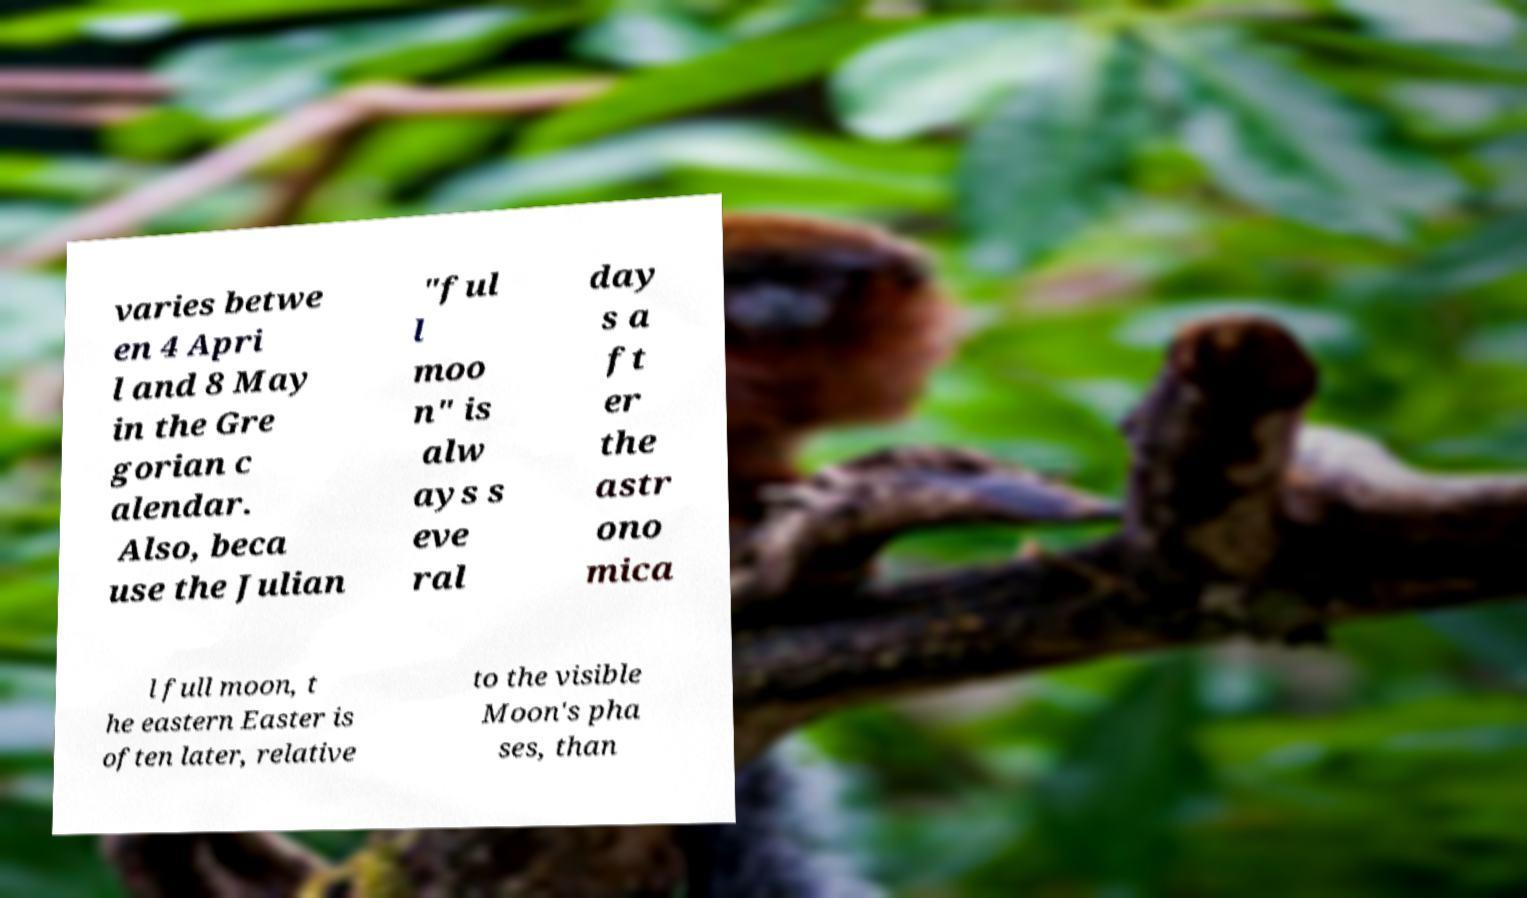Could you extract and type out the text from this image? varies betwe en 4 Apri l and 8 May in the Gre gorian c alendar. Also, beca use the Julian "ful l moo n" is alw ays s eve ral day s a ft er the astr ono mica l full moon, t he eastern Easter is often later, relative to the visible Moon's pha ses, than 